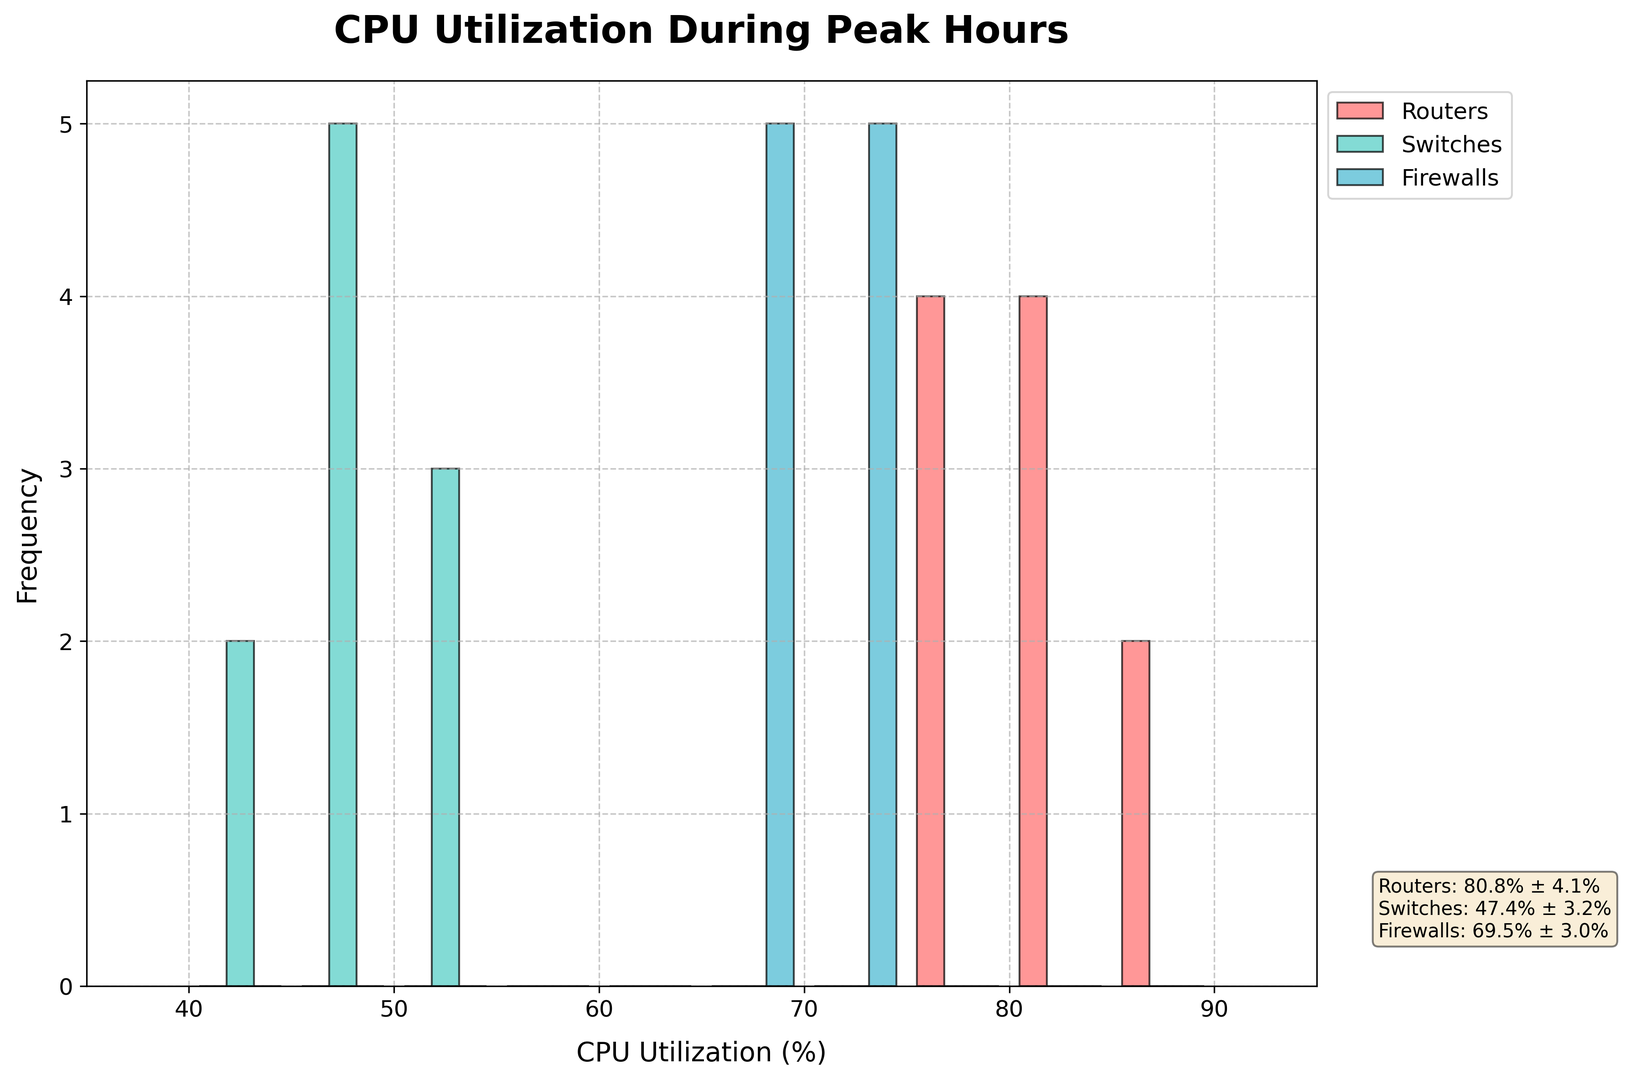What is the average CPU utilization percentage for routers? First, locate the routers' histogram (in red), then refer to the text box showing "Routers: 80.8% ± ...". The average CPU utilization for routers is 80.8%.
Answer: 80.8% Which type of network device has the lowest average CPU utilization? Refer to the text box summarizing statistics for all devices. Switches have "Switches: 47.4% ± ...", which is the lowest average among the devices.
Answer: Switches How does the average CPU utilization for firewalls compare to routers? The text box shows the average for firewalls as 69.5% and for routers as 80.8%. Compare the two values to find that firewalls have lower CPU utilization than routers.
Answer: Lower Which network device shows the highest peak in the histogram (highest bar)? Visually inspect the histogram and identify the tallest bar. The routers (red bars) show the highest peak compared to switches and firewalls.
Answer: Routers What is the range of CPU utilization percentages displayed on the x-axis? Look at the x-axis labels spanning the histogram. The range starts at 40% and ends at 90%.
Answer: 40% to 90% Which device shows the widest spread in CPU utilization? Inspect the extent of the bars for each device type. Routers show a wide spread from about 75% to 88%, which is wider than the other devices.
Answer: Routers Is the CPU utilization variability higher for switches or firewalls? The text box indicates standard deviations for switches and firewalls. Switches: ± 2.9%, Firewalls: ± 2.9%. Both have the same variability.
Answer: Same Which device type has the closest concentration of CPU utilization values? Observe the width of the histograms. Switches have a narrow spread, indicating values are closely concentrated.
Answer: Switches 